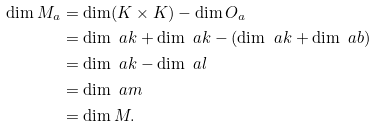Convert formula to latex. <formula><loc_0><loc_0><loc_500><loc_500>\dim M _ { a } & = \dim ( K \times K ) - \dim O _ { a } \\ & = \dim \ a k + \dim \ a k - ( \dim \ a k + \dim \ a b ) \\ & = \dim \ a k - \dim \ a l \\ & = \dim \ a m \\ & = \dim M .</formula> 